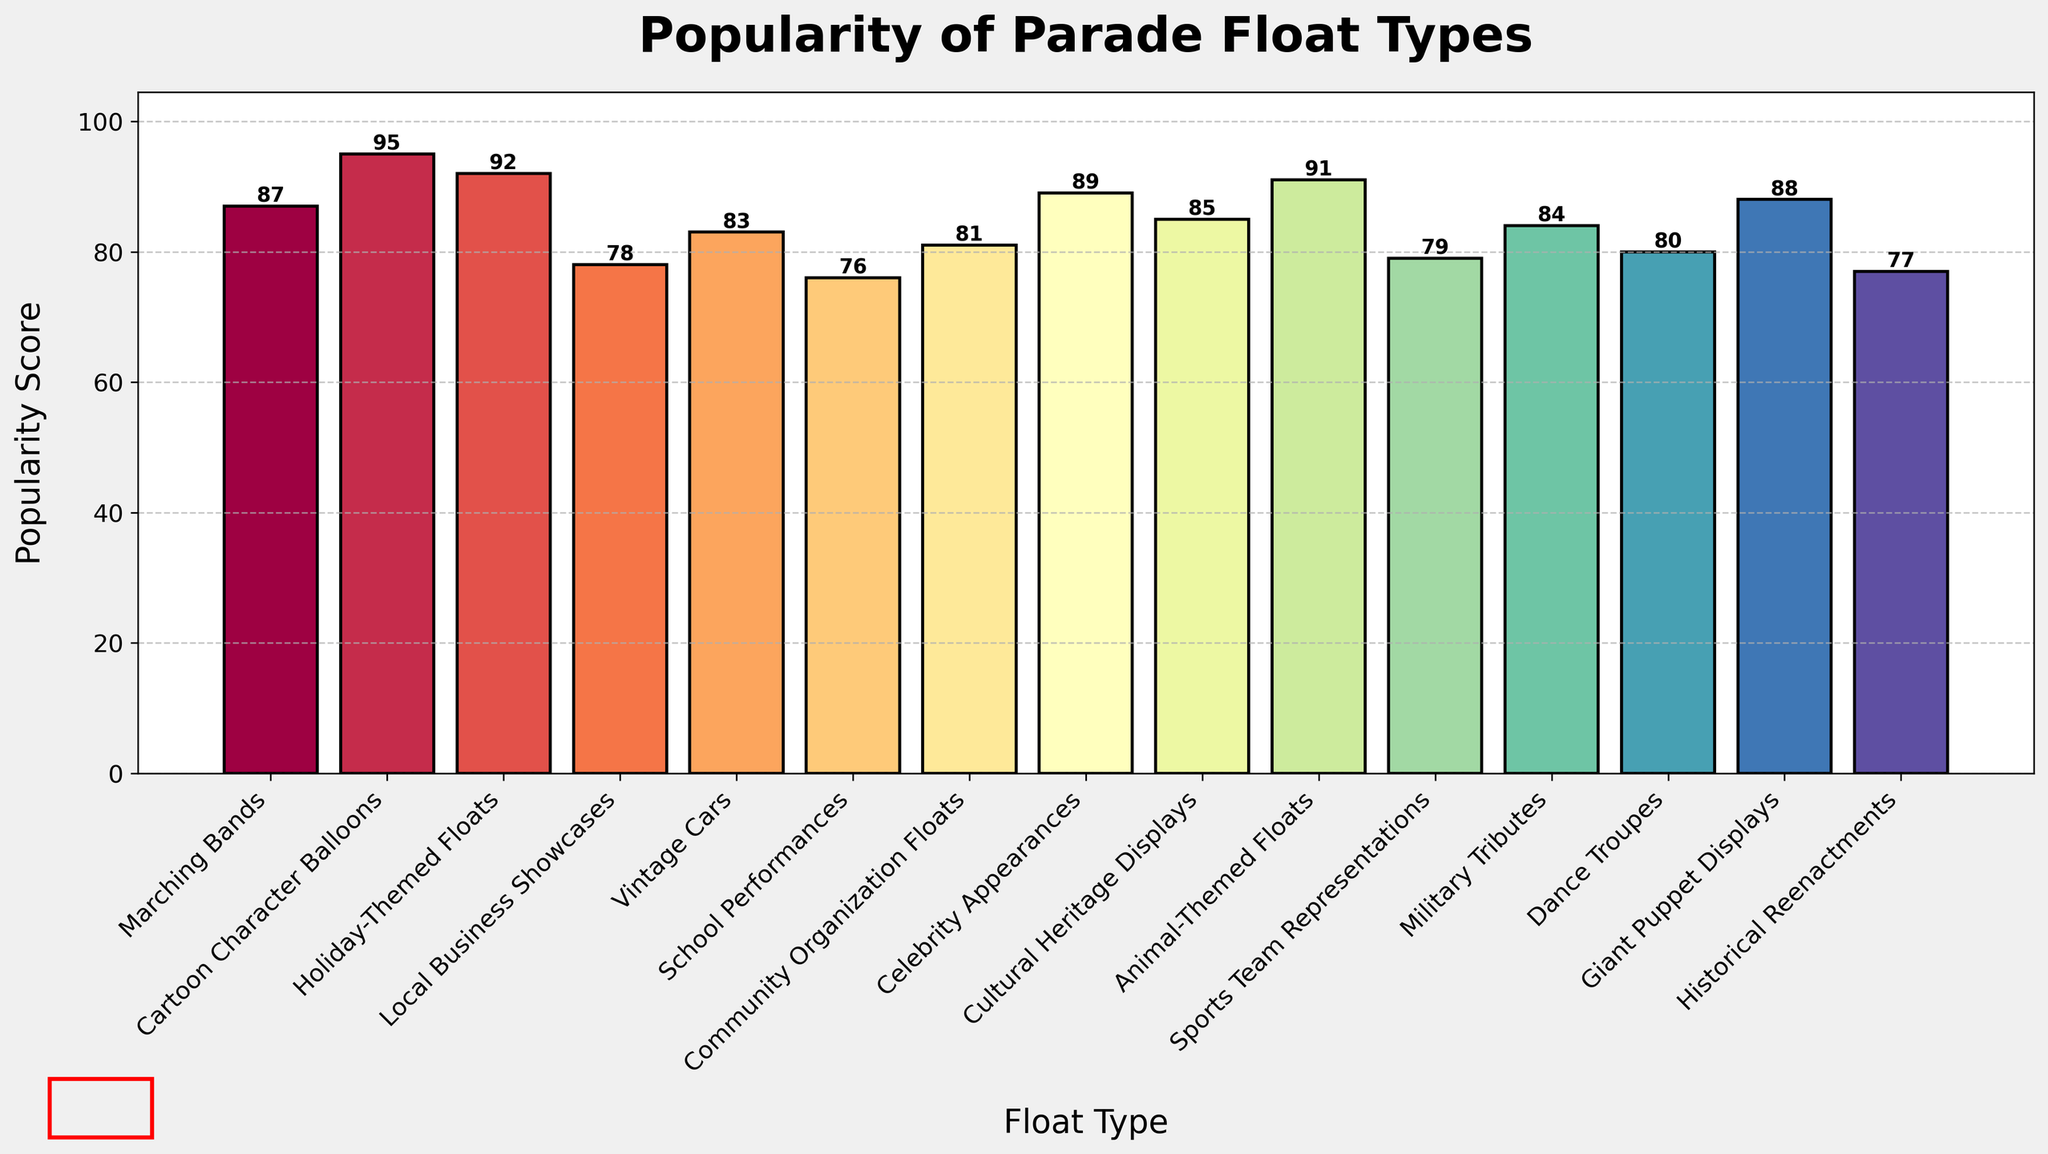Which float type has the highest popularity score? Look at the height of the bars and identify the tallest one. The Cartoon Character Balloons float has the highest bar.
Answer: Cartoon Character Balloons What is the average popularity score of all the float types? Add up all the popularity scores (87 + 95 + 92 + 78 + 83 + 76 + 81 + 89 + 85 + 91 + 79 + 84 + 80 + 88 + 77) to get 1285, then divide by the number of float types (which is 15). The average is 1285 / 15.
Answer: 85.67 Are Holiday-Themed Floats more popular than Local Business Showcases? Compare the height of the Holiday-Themed Floats bar (92) with the Local Business Showcases bar (78). Since 92 is greater than 78, Holiday-Themed Floats are more popular.
Answer: Yes Which float types have a popularity score greater than 90? Locate the bars higher than 90: Cartoon Character Balloons (95), Holiday-Themed Floats (92), and Animal-Themed Floats (91).
Answer: Cartoon Character Balloons, Holiday-Themed Floats, Animal-Themed Floats What is the difference in popularity score between the highest and the lowest float types? Identify the highest score (Cartoon Character Balloons with 95) and the lowest score (School Performances with 76), then subtract the two: 95 - 76.
Answer: 19 How many float types have a popularity score below 80? Count the bars with scores below 80: Local Business Showcases (78), School Performances (76), Sports Team Representations (79), Historical Reenactments (77). There are 4 such bars.
Answer: 4 What is the combined popularity score of Community Organization Floats and Military Tributes? Add the popularity scores of Community Organization Floats (81) and Military Tributes (84) together: 81 + 84.
Answer: 165 Do Marching Bands and Dance Troupes have similar popularity scores? Compare the scores of Marching Bands (87) and Dance Troupes (80). They are close, but not the same.
Answer: No Which float type has the second highest popularity score? Identify the second tallest bar after Cartoon Character Balloons (95). The next tallest bar is Holiday-Themed Floats (92).
Answer: Holiday-Themed Floats What is the average popularity score of the float types that score above 85? Identify the float types with scores above 85: Marching Bands (87), Cartoon Character Balloons (95), Holiday-Themed Floats (92), Celebrity Appearances (89), Animal-Themed Floats (91), Giant Puppet Displays (88). Sum these scores: 87 + 95 + 92 + 89 + 91 + 88 = 542. Divide by the number of float types (6). The average is 542 / 6.
Answer: 90.33 